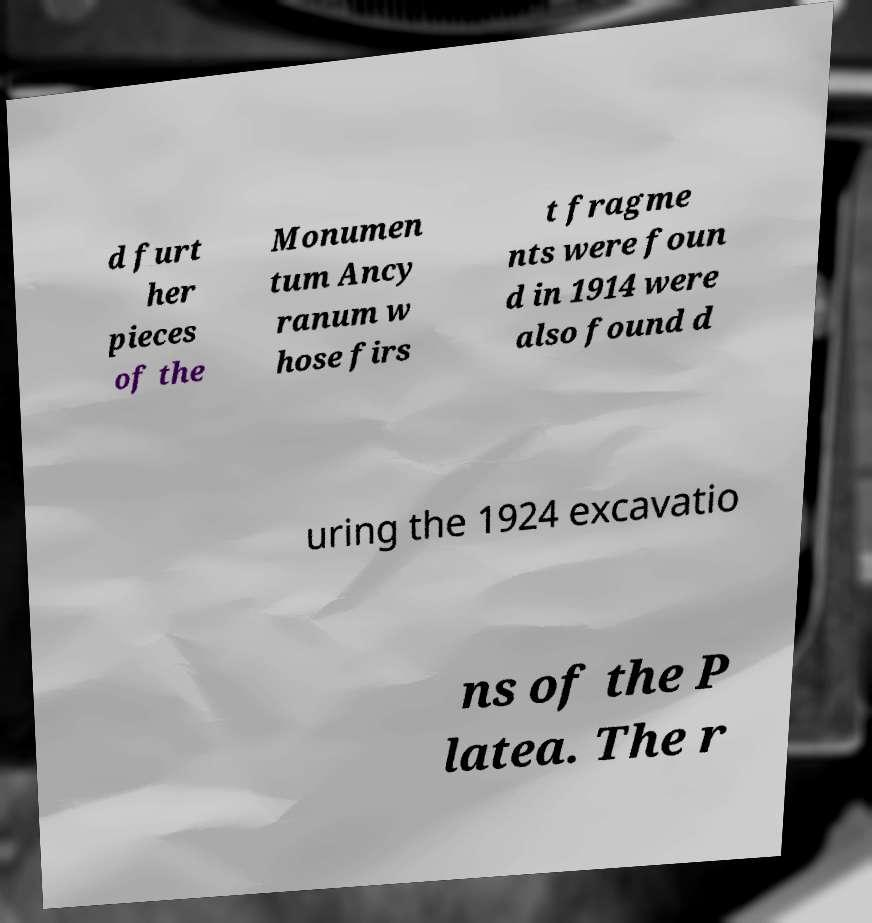Could you assist in decoding the text presented in this image and type it out clearly? d furt her pieces of the Monumen tum Ancy ranum w hose firs t fragme nts were foun d in 1914 were also found d uring the 1924 excavatio ns of the P latea. The r 